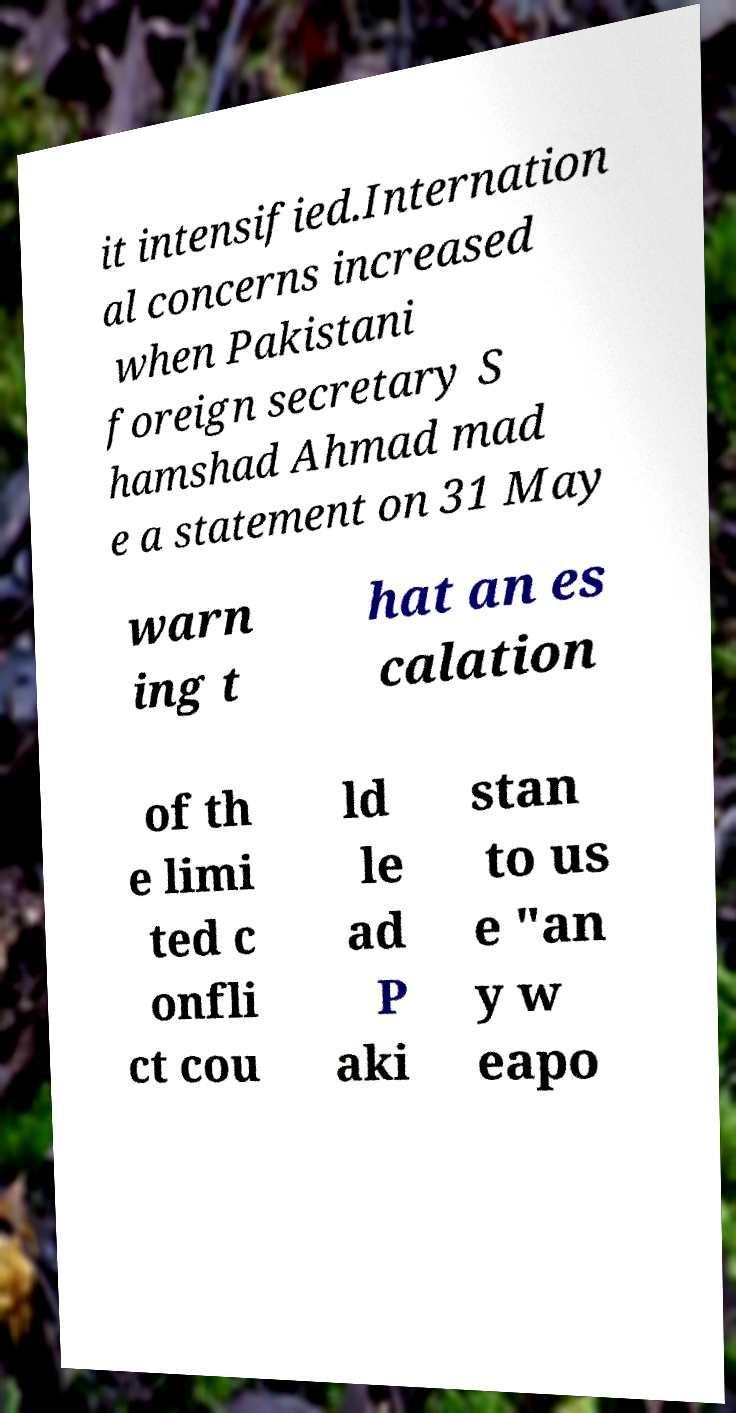Can you read and provide the text displayed in the image?This photo seems to have some interesting text. Can you extract and type it out for me? it intensified.Internation al concerns increased when Pakistani foreign secretary S hamshad Ahmad mad e a statement on 31 May warn ing t hat an es calation of th e limi ted c onfli ct cou ld le ad P aki stan to us e "an y w eapo 